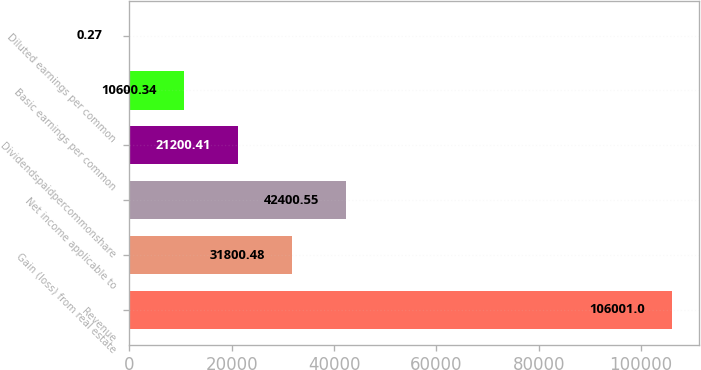Convert chart to OTSL. <chart><loc_0><loc_0><loc_500><loc_500><bar_chart><fcel>Revenue<fcel>Gain (loss) from real estate<fcel>Net income applicable to<fcel>Dividendspaidpercommonshare<fcel>Basic earnings per common<fcel>Diluted earnings per common<nl><fcel>106001<fcel>31800.5<fcel>42400.6<fcel>21200.4<fcel>10600.3<fcel>0.27<nl></chart> 